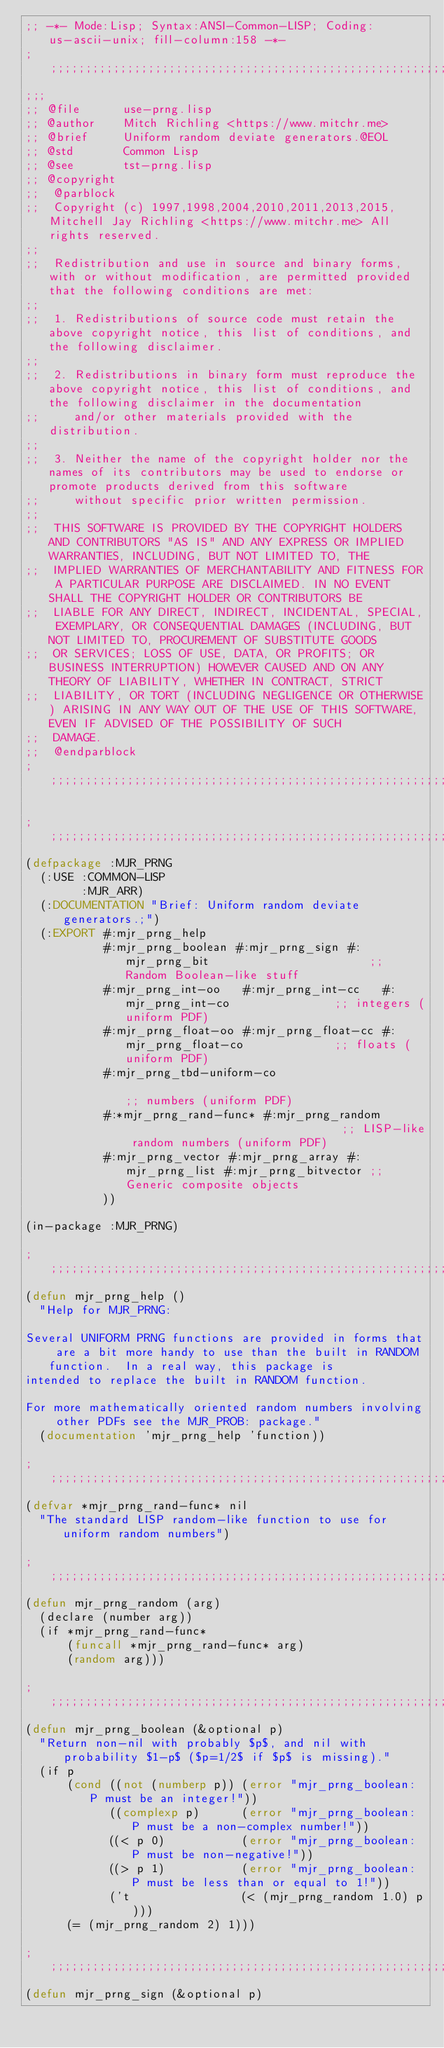Convert code to text. <code><loc_0><loc_0><loc_500><loc_500><_Lisp_>;; -*- Mode:Lisp; Syntax:ANSI-Common-LISP; Coding:us-ascii-unix; fill-column:158 -*-
;;;;;;;;;;;;;;;;;;;;;;;;;;;;;;;;;;;;;;;;;;;;;;;;;;;;;;;;;;;;;;;;;;;;;;;;;;;;;;;;;;;;;;;;;;;;;;;;;;;;;;;;;;;;;;;;;;;;;;;;;;;;;;;;;;;;;;;;;;;;;;;;;;;;;;;;;;;;;;;;
;;;
;; @file      use-prng.lisp
;; @author    Mitch Richling <https://www.mitchr.me>
;; @brief     Uniform random deviate generators.@EOL
;; @std       Common Lisp
;; @see       tst-prng.lisp
;; @copyright
;;  @parblock
;;  Copyright (c) 1997,1998,2004,2010,2011,2013,2015, Mitchell Jay Richling <https://www.mitchr.me> All rights reserved.
;;
;;  Redistribution and use in source and binary forms, with or without modification, are permitted provided that the following conditions are met:
;;
;;  1. Redistributions of source code must retain the above copyright notice, this list of conditions, and the following disclaimer.
;;
;;  2. Redistributions in binary form must reproduce the above copyright notice, this list of conditions, and the following disclaimer in the documentation
;;     and/or other materials provided with the distribution.
;;
;;  3. Neither the name of the copyright holder nor the names of its contributors may be used to endorse or promote products derived from this software
;;     without specific prior written permission.
;;
;;  THIS SOFTWARE IS PROVIDED BY THE COPYRIGHT HOLDERS AND CONTRIBUTORS "AS IS" AND ANY EXPRESS OR IMPLIED WARRANTIES, INCLUDING, BUT NOT LIMITED TO, THE
;;  IMPLIED WARRANTIES OF MERCHANTABILITY AND FITNESS FOR A PARTICULAR PURPOSE ARE DISCLAIMED. IN NO EVENT SHALL THE COPYRIGHT HOLDER OR CONTRIBUTORS BE
;;  LIABLE FOR ANY DIRECT, INDIRECT, INCIDENTAL, SPECIAL, EXEMPLARY, OR CONSEQUENTIAL DAMAGES (INCLUDING, BUT NOT LIMITED TO, PROCUREMENT OF SUBSTITUTE GOODS
;;  OR SERVICES; LOSS OF USE, DATA, OR PROFITS; OR BUSINESS INTERRUPTION) HOWEVER CAUSED AND ON ANY THEORY OF LIABILITY, WHETHER IN CONTRACT, STRICT
;;  LIABILITY, OR TORT (INCLUDING NEGLIGENCE OR OTHERWISE) ARISING IN ANY WAY OUT OF THE USE OF THIS SOFTWARE, EVEN IF ADVISED OF THE POSSIBILITY OF SUCH
;;  DAMAGE.
;;  @endparblock
;;;;;;;;;;;;;;;;;;;;;;;;;;;;;;;;;;;;;;;;;;;;;;;;;;;;;;;;;;;;;;;;;;;;;;;;;;;;;;;;;;;;;;;;;;;;;;;;;;;;;;;;;;;;;;;;;;;;;;;;;;;;;;;;;;;;;;;;;;;;;;;;;;;;;;;;;;;;;;;;

;;;;;;;;;;;;;;;;;;;;;;;;;;;;;;;;;;;;;;;;;;;;;;;;;;;;;;;;;;;;;;;;;;;;;;;;;;;;;;;;;;;;;;;;;;;;;;;;;;;;;;;;;;;;;;;;;;;;;;;;;;;;;;;;;;;;;;;;;;;;;;;;;;;;;;;;;;;;;;;;
(defpackage :MJR_PRNG
  (:USE :COMMON-LISP
        :MJR_ARR)
  (:DOCUMENTATION "Brief: Uniform random deviate generators.;")
  (:EXPORT #:mjr_prng_help
           #:mjr_prng_boolean #:mjr_prng_sign #:mjr_prng_bit                       ;; Random Boolean-like stuff
           #:mjr_prng_int-oo   #:mjr_prng_int-cc   #:mjr_prng_int-co               ;; integers (uniform PDF)
           #:mjr_prng_float-oo #:mjr_prng_float-cc #:mjr_prng_float-co             ;; floats (uniform PDF)
           #:mjr_prng_tbd-uniform-co                                               ;; numbers (uniform PDF)
           #:*mjr_prng_rand-func* #:mjr_prng_random                                ;; LISP-like random numbers (uniform PDF)
           #:mjr_prng_vector #:mjr_prng_array #:mjr_prng_list #:mjr_prng_bitvector ;; Generic composite objects
           ))

(in-package :MJR_PRNG)

;;;;;;;;;;;;;;;;;;;;;;;;;;;;;;;;;;;;;;;;;;;;;;;;;;;;;;;;;;;;;;;;;;;;;;;;;;;;;;;;;;;;;;;;;;;;;;;;;;;;;;;;;;;;;;;;;;;;;;;;;;;;;;;;;;;;;;;;;;;;;;;;;;;;;;;;;;;;;;;;
(defun mjr_prng_help ()
  "Help for MJR_PRNG:

Several UNIFORM PRNG functions are provided in forms that are a bit more handy to use than the built in RANDOM function.  In a real way, this package is
intended to replace the built in RANDOM function.

For more mathematically oriented random numbers involving other PDFs see the MJR_PROB: package."
  (documentation 'mjr_prng_help 'function))

;;;;;;;;;;;;;;;;;;;;;;;;;;;;;;;;;;;;;;;;;;;;;;;;;;;;;;;;;;;;;;;;;;;;;;;;;;;;;;;;;;;;;;;;;;;;;;;;;;;;;;;;;;;;;;;;;;;;;;;;;;;;;;;;;;;;;;;;;;;;;;;;;;;;;;;;;;;;;;;;
(defvar *mjr_prng_rand-func* nil
  "The standard LISP random-like function to use for uniform random numbers")

;;;;;;;;;;;;;;;;;;;;;;;;;;;;;;;;;;;;;;;;;;;;;;;;;;;;;;;;;;;;;;;;;;;;;;;;;;;;;;;;;;;;;;;;;;;;;;;;;;;;;;;;;;;;;;;;;;;;;;;;;;;;;;;;;;;;;;;;;;;;;;;;;;;;;;;;;;;;;;;;
(defun mjr_prng_random (arg)
  (declare (number arg))
  (if *mjr_prng_rand-func*
      (funcall *mjr_prng_rand-func* arg)
      (random arg)))

;;;;;;;;;;;;;;;;;;;;;;;;;;;;;;;;;;;;;;;;;;;;;;;;;;;;;;;;;;;;;;;;;;;;;;;;;;;;;;;;;;;;;;;;;;;;;;;;;;;;;;;;;;;;;;;;;;;;;;;;;;;;;;;;;;;;;;;;;;;;;;;;;;;;;;;;;;;;;;;;
(defun mjr_prng_boolean (&optional p)
  "Return non-nil with probably $p$, and nil with probability $1-p$ ($p=1/2$ if $p$ is missing)."
  (if p
      (cond ((not (numberp p)) (error "mjr_prng_boolean: P must be an integer!"))
            ((complexp p)      (error "mjr_prng_boolean: P must be a non-complex number!"))
            ((< p 0)           (error "mjr_prng_boolean: P must be non-negative!"))
            ((> p 1)           (error "mjr_prng_boolean: P must be less than or equal to 1!"))
            ('t                (< (mjr_prng_random 1.0) p)))
      (= (mjr_prng_random 2) 1)))

;;;;;;;;;;;;;;;;;;;;;;;;;;;;;;;;;;;;;;;;;;;;;;;;;;;;;;;;;;;;;;;;;;;;;;;;;;;;;;;;;;;;;;;;;;;;;;;;;;;;;;;;;;;;;;;;;;;;;;;;;;;;;;;;;;;;;;;;;;;;;;;;;;;;;;;;;;;;;;;;
(defun mjr_prng_sign (&optional p)</code> 